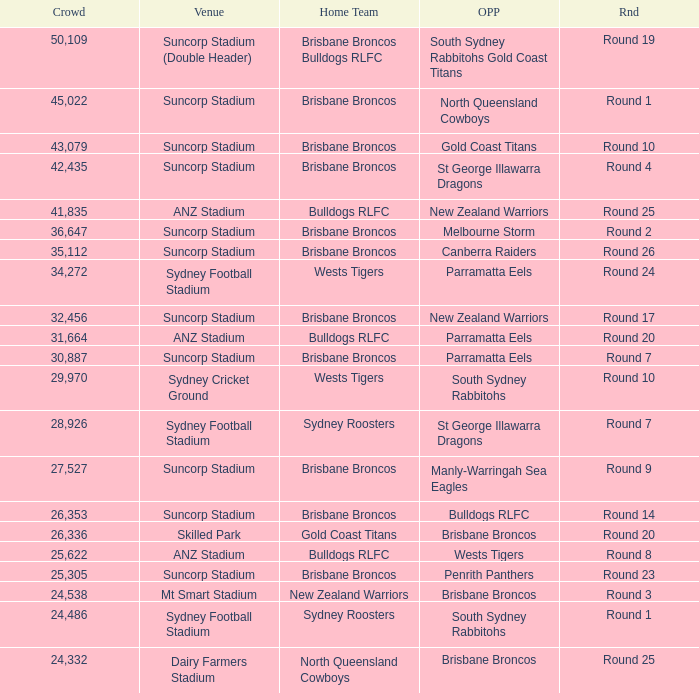What was the attendance at Round 9? 1.0. 